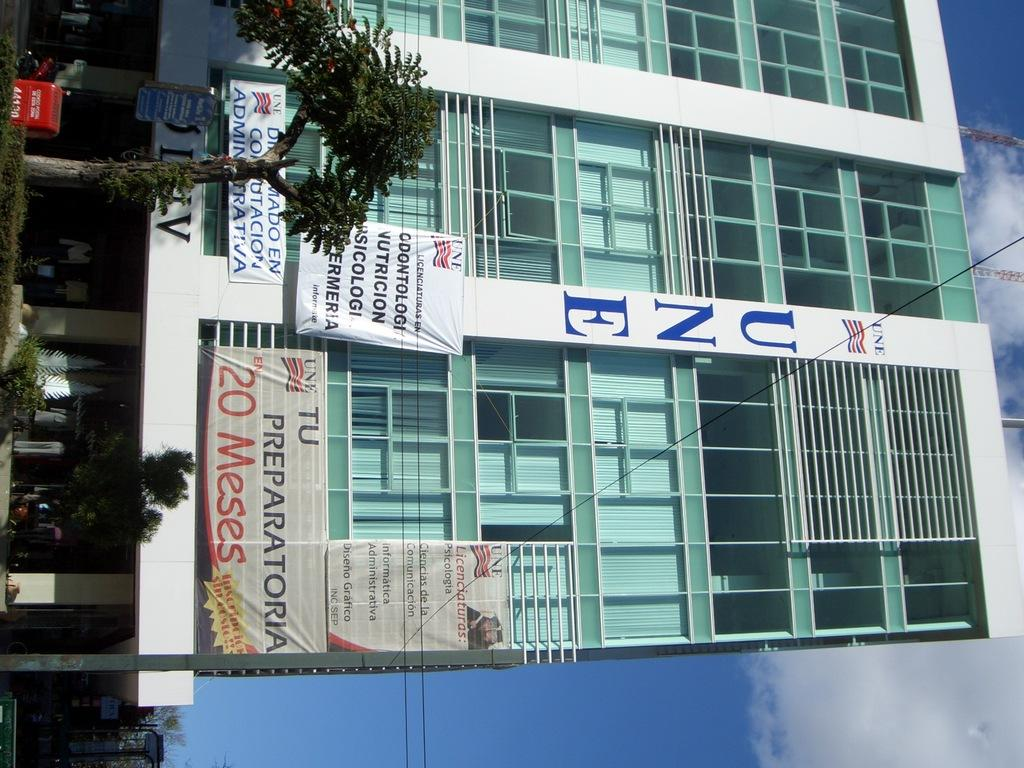What is the main subject in the center of the image? There is a building in the center of the image. What type of objects can be seen near the building? Boards are visible in the image. What type of natural elements are present in the image? There are trees in the image. What can be seen in the background of the image? The sky is visible in the background of the image. What type of attraction can be seen in the image? There is no attraction present in the image; it features a building, boards, trees, and the sky. What mark is visible on the building in the image? There is no mark visible on the building in the image. 